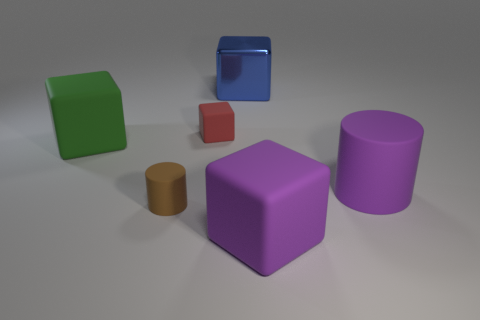There is a cylinder that is on the right side of the red rubber cube; does it have the same color as the small matte cylinder? No, the cylinder on the right side of the red rubber cube does not have the same color as the small matte cylinder. The cylinder in question appears to be a shade of brown, while the small matte cylinder is a shade of orange. 